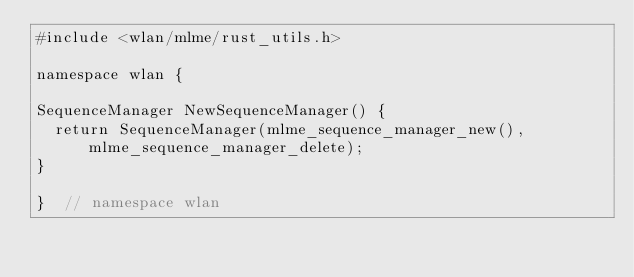Convert code to text. <code><loc_0><loc_0><loc_500><loc_500><_C++_>#include <wlan/mlme/rust_utils.h>

namespace wlan {

SequenceManager NewSequenceManager() {
  return SequenceManager(mlme_sequence_manager_new(), mlme_sequence_manager_delete);
}

}  // namespace wlan
</code> 